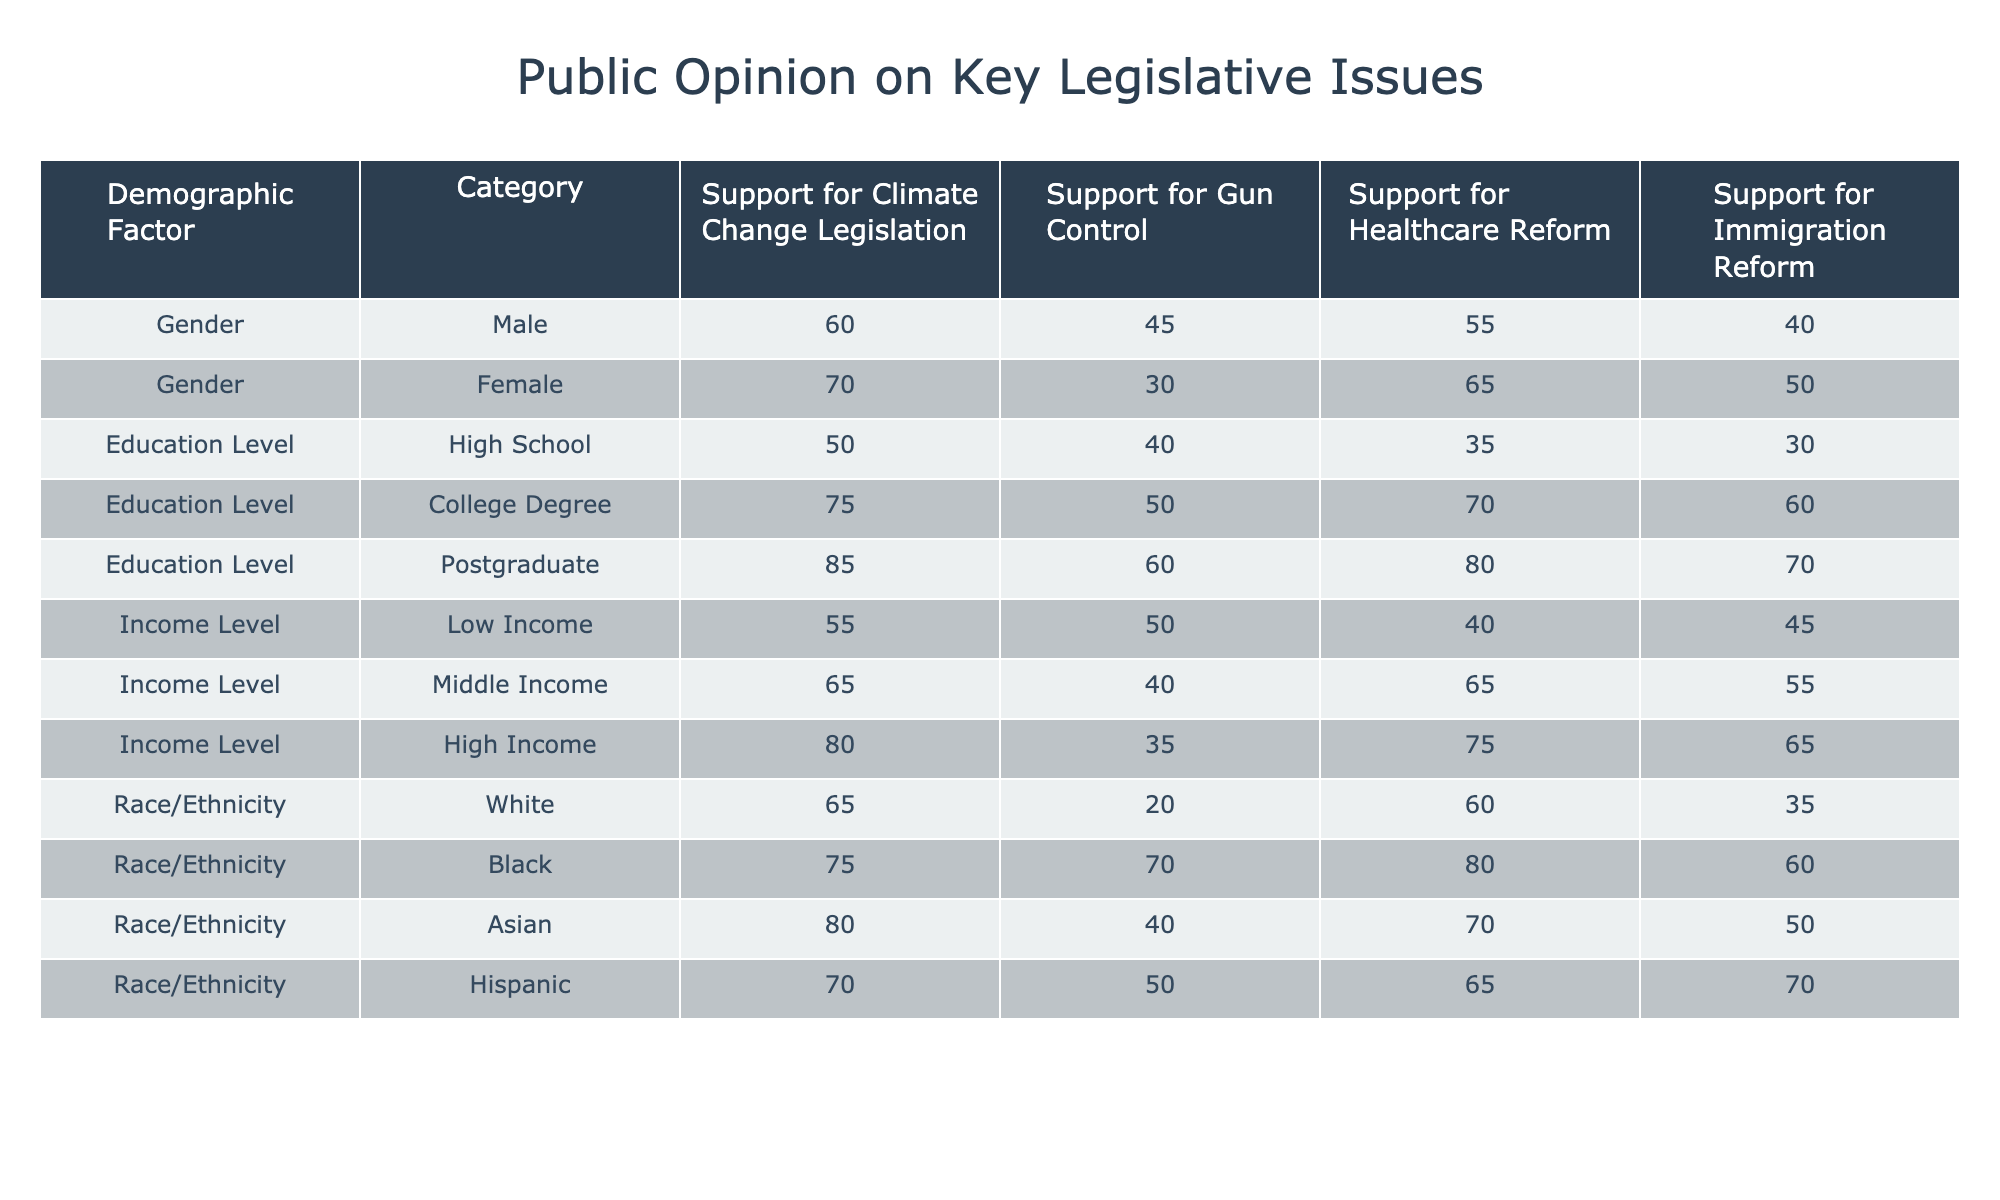What percentage of males support gun control legislation? From the table, we can see that 45% of males support gun control legislation under the "Gender" demographic factor.
Answer: 45% Which demographic group shows the highest support for healthcare reform? We can compare the percentages for healthcare reform across all groups. The highest percentage is 80% among the Black demographic group.
Answer: 80% Is the support for climate change legislation higher among those with postgraduate education compared to those with a high school education? The support for climate change legislation is 85% for postgraduate education and 50% for high school education. Since 85% is greater than 50%, the statement is true.
Answer: Yes What is the average support for immigration reform across all income levels? We gather the immigration reform support percentages: 45 (Low Income) + 55 (Middle Income) + 65 (High Income) = 165. There are 3 data points, so the average is 165/3 = 55%.
Answer: 55% Do more females than males support climate change legislation? From the table, we see that 70% of females support climate change legislation, while only 60% of males do. Since 70% is greater than 60%, the statement is true.
Answer: Yes What is the difference in support for gun control legislation between the Black and Hispanic demographic groups? The Black group supports gun control at 70%, while the Hispanic group supports it at 50%. The difference is 70 - 50 = 20%.
Answer: 20% What percentage of individuals with a college degree support immigration reform? According to the table, individuals with a college degree support immigration reform at 60%.
Answer: 60% Which demographic group has the lowest support for climate change legislation? Upon reviewing the climate change support percentages, the Low Income group shows the lowest support at 55%.
Answer: 55% Are there any demographic groups where the support for healthcare reform is 40% or lower? Looking at the table, the only group that has support for healthcare reform at 40% is the Low Income group. Thus, we conclude there's one such group.
Answer: Yes 